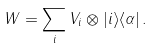<formula> <loc_0><loc_0><loc_500><loc_500>W = \sum _ { i } V _ { i } \otimes | i \rangle \langle \alpha | \, .</formula> 